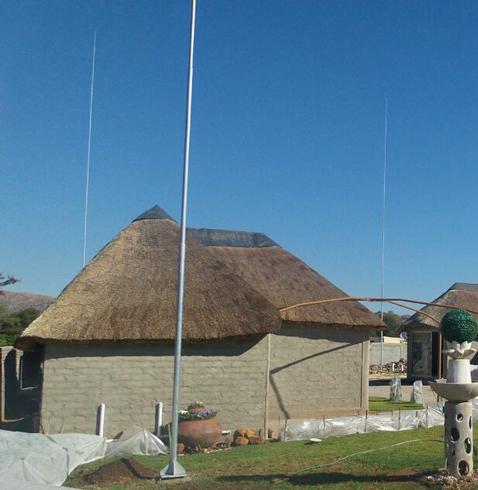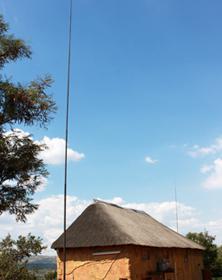The first image is the image on the left, the second image is the image on the right. Analyze the images presented: Is the assertion "One of the houses has at least one chimney." valid? Answer yes or no. No. The first image is the image on the left, the second image is the image on the right. Considering the images on both sides, is "The left and right image contains the same number of of poles to the to one side of the house." valid? Answer yes or no. Yes. 